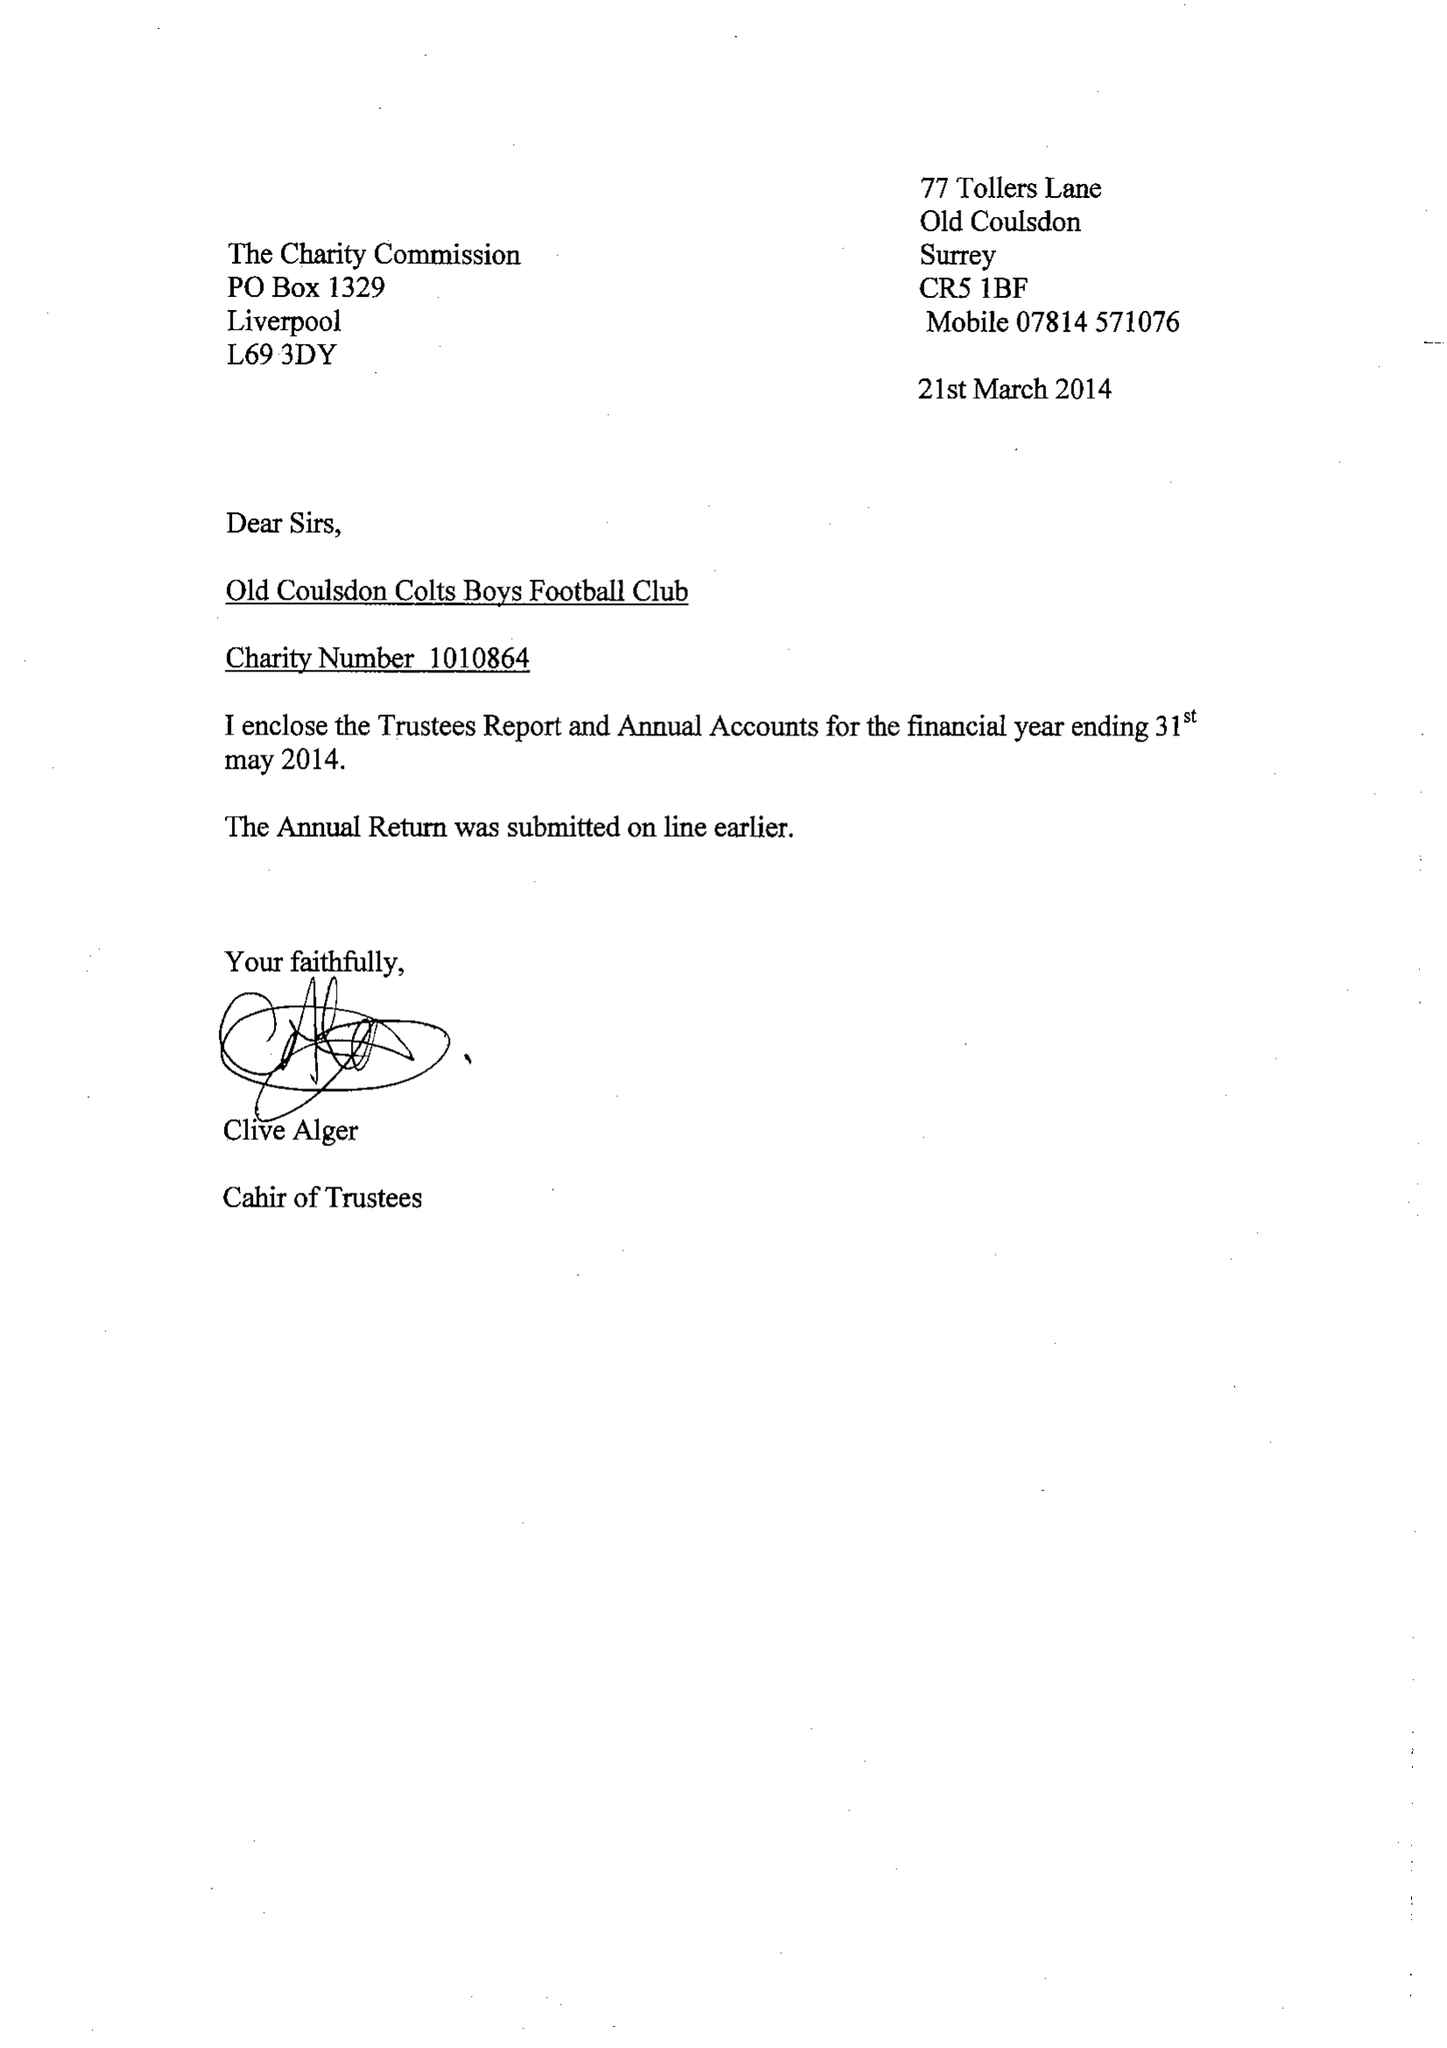What is the value for the report_date?
Answer the question using a single word or phrase. 2014-05-31 